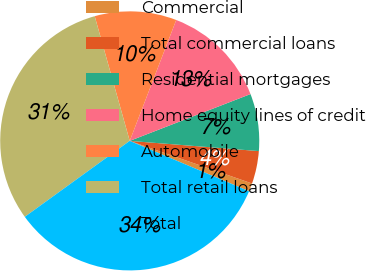Convert chart. <chart><loc_0><loc_0><loc_500><loc_500><pie_chart><fcel>Commercial<fcel>Total commercial loans<fcel>Residential mortgages<fcel>Home equity lines of credit<fcel>Automobile<fcel>Total retail loans<fcel>Total<nl><fcel>1.02%<fcel>4.08%<fcel>7.14%<fcel>13.27%<fcel>10.2%<fcel>30.61%<fcel>33.67%<nl></chart> 